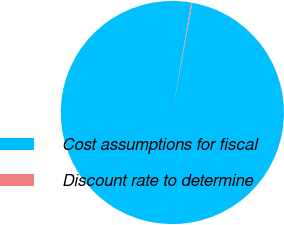Convert chart to OTSL. <chart><loc_0><loc_0><loc_500><loc_500><pie_chart><fcel>Cost assumptions for fiscal<fcel>Discount rate to determine<nl><fcel>99.87%<fcel>0.13%<nl></chart> 